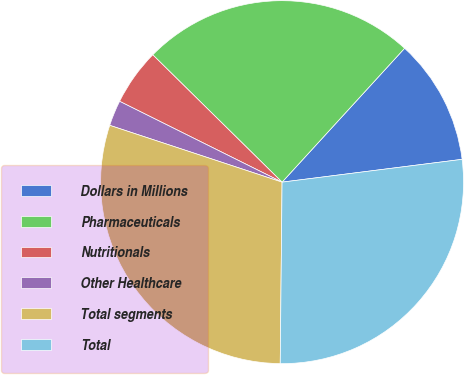Convert chart. <chart><loc_0><loc_0><loc_500><loc_500><pie_chart><fcel>Dollars in Millions<fcel>Pharmaceuticals<fcel>Nutritionals<fcel>Other Healthcare<fcel>Total segments<fcel>Total<nl><fcel>11.2%<fcel>24.42%<fcel>5.03%<fcel>2.28%<fcel>29.91%<fcel>27.17%<nl></chart> 